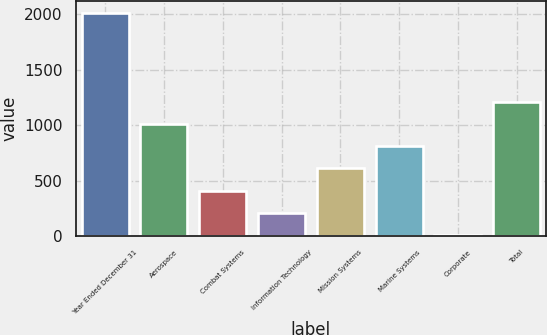Convert chart. <chart><loc_0><loc_0><loc_500><loc_500><bar_chart><fcel>Year Ended December 31<fcel>Aerospace<fcel>Combat Systems<fcel>Information Technology<fcel>Mission Systems<fcel>Marine Systems<fcel>Corporate<fcel>Total<nl><fcel>2016<fcel>1011.5<fcel>408.8<fcel>207.9<fcel>609.7<fcel>810.6<fcel>7<fcel>1212.4<nl></chart> 